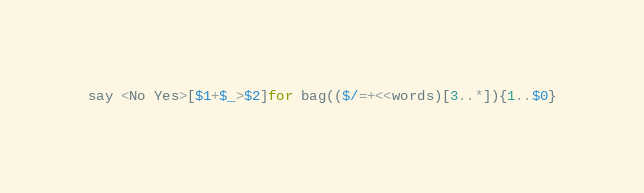<code> <loc_0><loc_0><loc_500><loc_500><_Perl_>say <No Yes>[$1+$_>$2]for bag(($/=+<<words)[3..*]){1..$0}</code> 